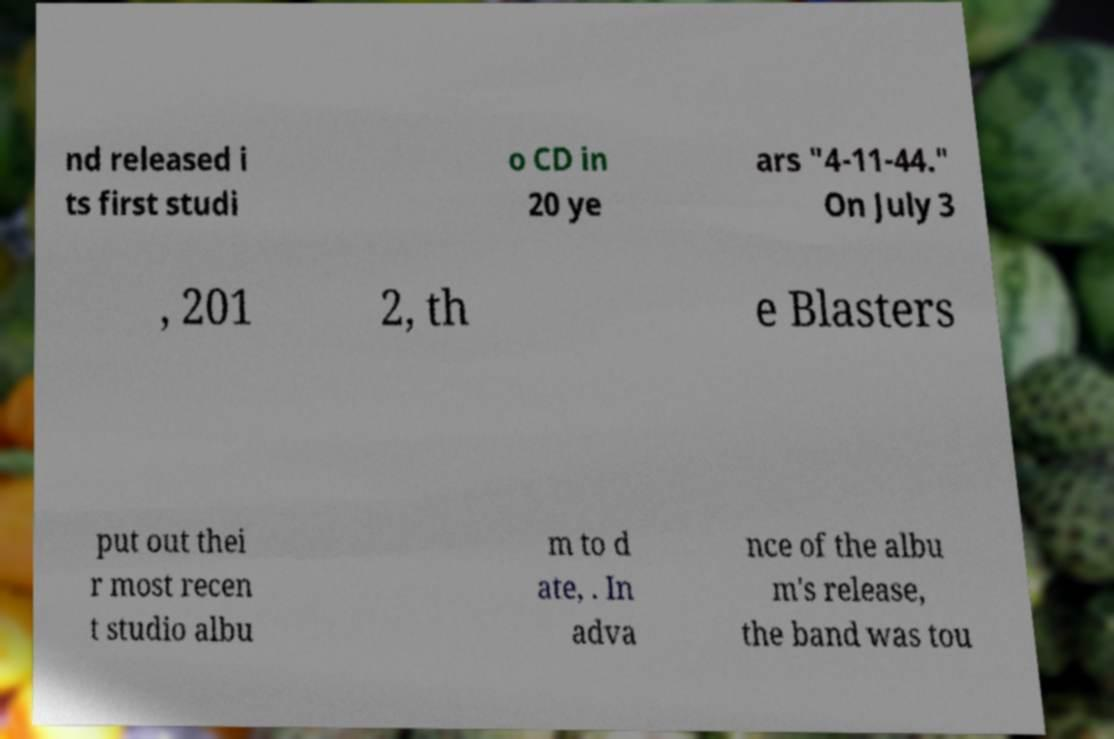There's text embedded in this image that I need extracted. Can you transcribe it verbatim? nd released i ts first studi o CD in 20 ye ars "4-11-44." On July 3 , 201 2, th e Blasters put out thei r most recen t studio albu m to d ate, . In adva nce of the albu m's release, the band was tou 